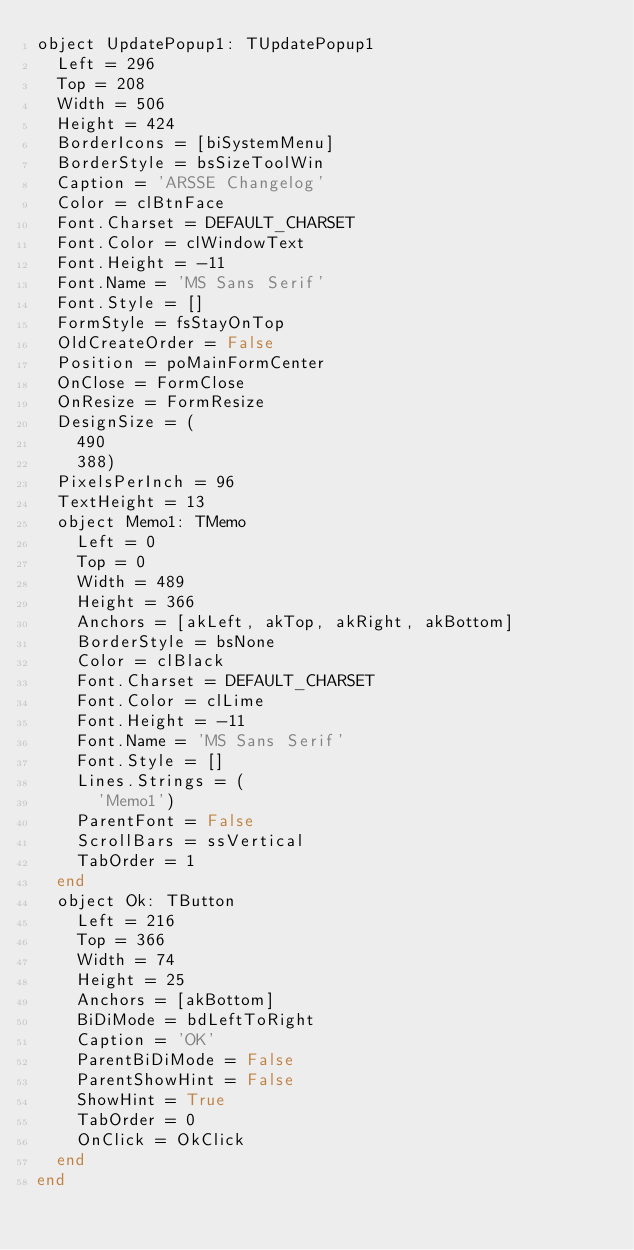<code> <loc_0><loc_0><loc_500><loc_500><_Pascal_>object UpdatePopup1: TUpdatePopup1
  Left = 296
  Top = 208
  Width = 506
  Height = 424
  BorderIcons = [biSystemMenu]
  BorderStyle = bsSizeToolWin
  Caption = 'ARSSE Changelog'
  Color = clBtnFace
  Font.Charset = DEFAULT_CHARSET
  Font.Color = clWindowText
  Font.Height = -11
  Font.Name = 'MS Sans Serif'
  Font.Style = []
  FormStyle = fsStayOnTop
  OldCreateOrder = False
  Position = poMainFormCenter
  OnClose = FormClose
  OnResize = FormResize
  DesignSize = (
    490
    388)
  PixelsPerInch = 96
  TextHeight = 13
  object Memo1: TMemo
    Left = 0
    Top = 0
    Width = 489
    Height = 366
    Anchors = [akLeft, akTop, akRight, akBottom]
    BorderStyle = bsNone
    Color = clBlack
    Font.Charset = DEFAULT_CHARSET
    Font.Color = clLime
    Font.Height = -11
    Font.Name = 'MS Sans Serif'
    Font.Style = []
    Lines.Strings = (
      'Memo1')
    ParentFont = False
    ScrollBars = ssVertical
    TabOrder = 1
  end
  object Ok: TButton
    Left = 216
    Top = 366
    Width = 74
    Height = 25
    Anchors = [akBottom]
    BiDiMode = bdLeftToRight
    Caption = 'OK'
    ParentBiDiMode = False
    ParentShowHint = False
    ShowHint = True
    TabOrder = 0
    OnClick = OkClick
  end
end
</code> 